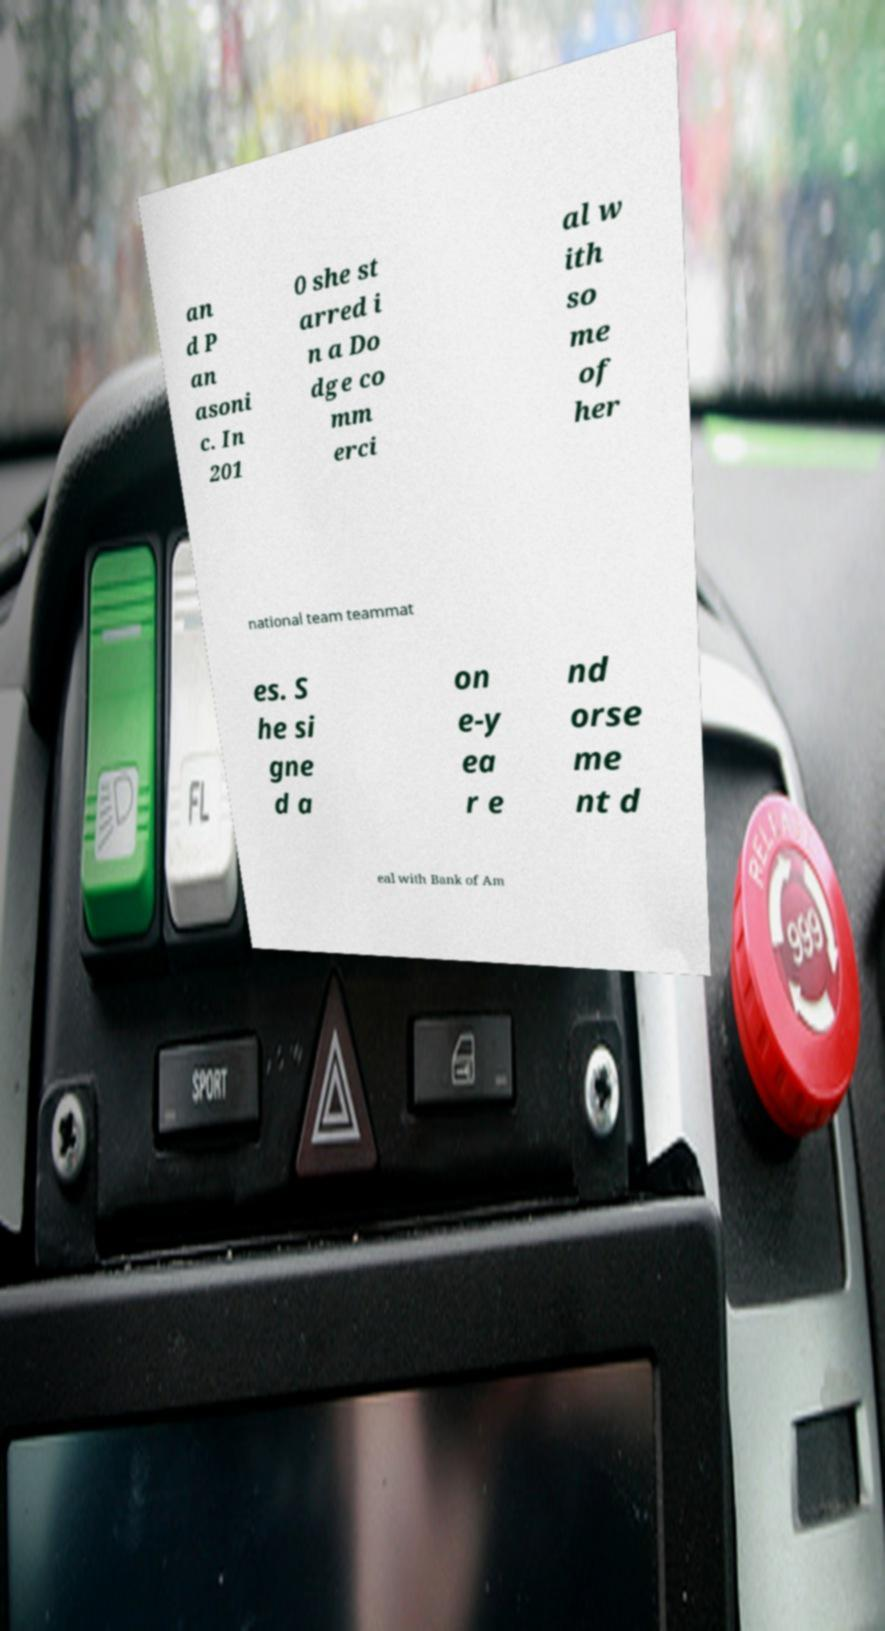Can you accurately transcribe the text from the provided image for me? an d P an asoni c. In 201 0 she st arred i n a Do dge co mm erci al w ith so me of her national team teammat es. S he si gne d a on e-y ea r e nd orse me nt d eal with Bank of Am 